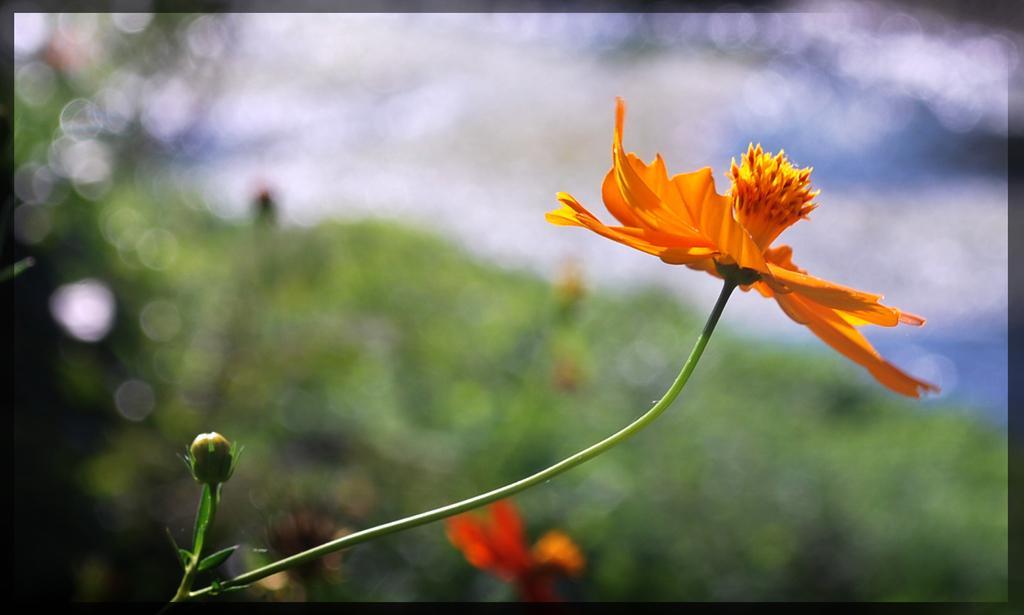Describe this image in one or two sentences. In this image I can see the flower in orange color and the background is in white and green color. 